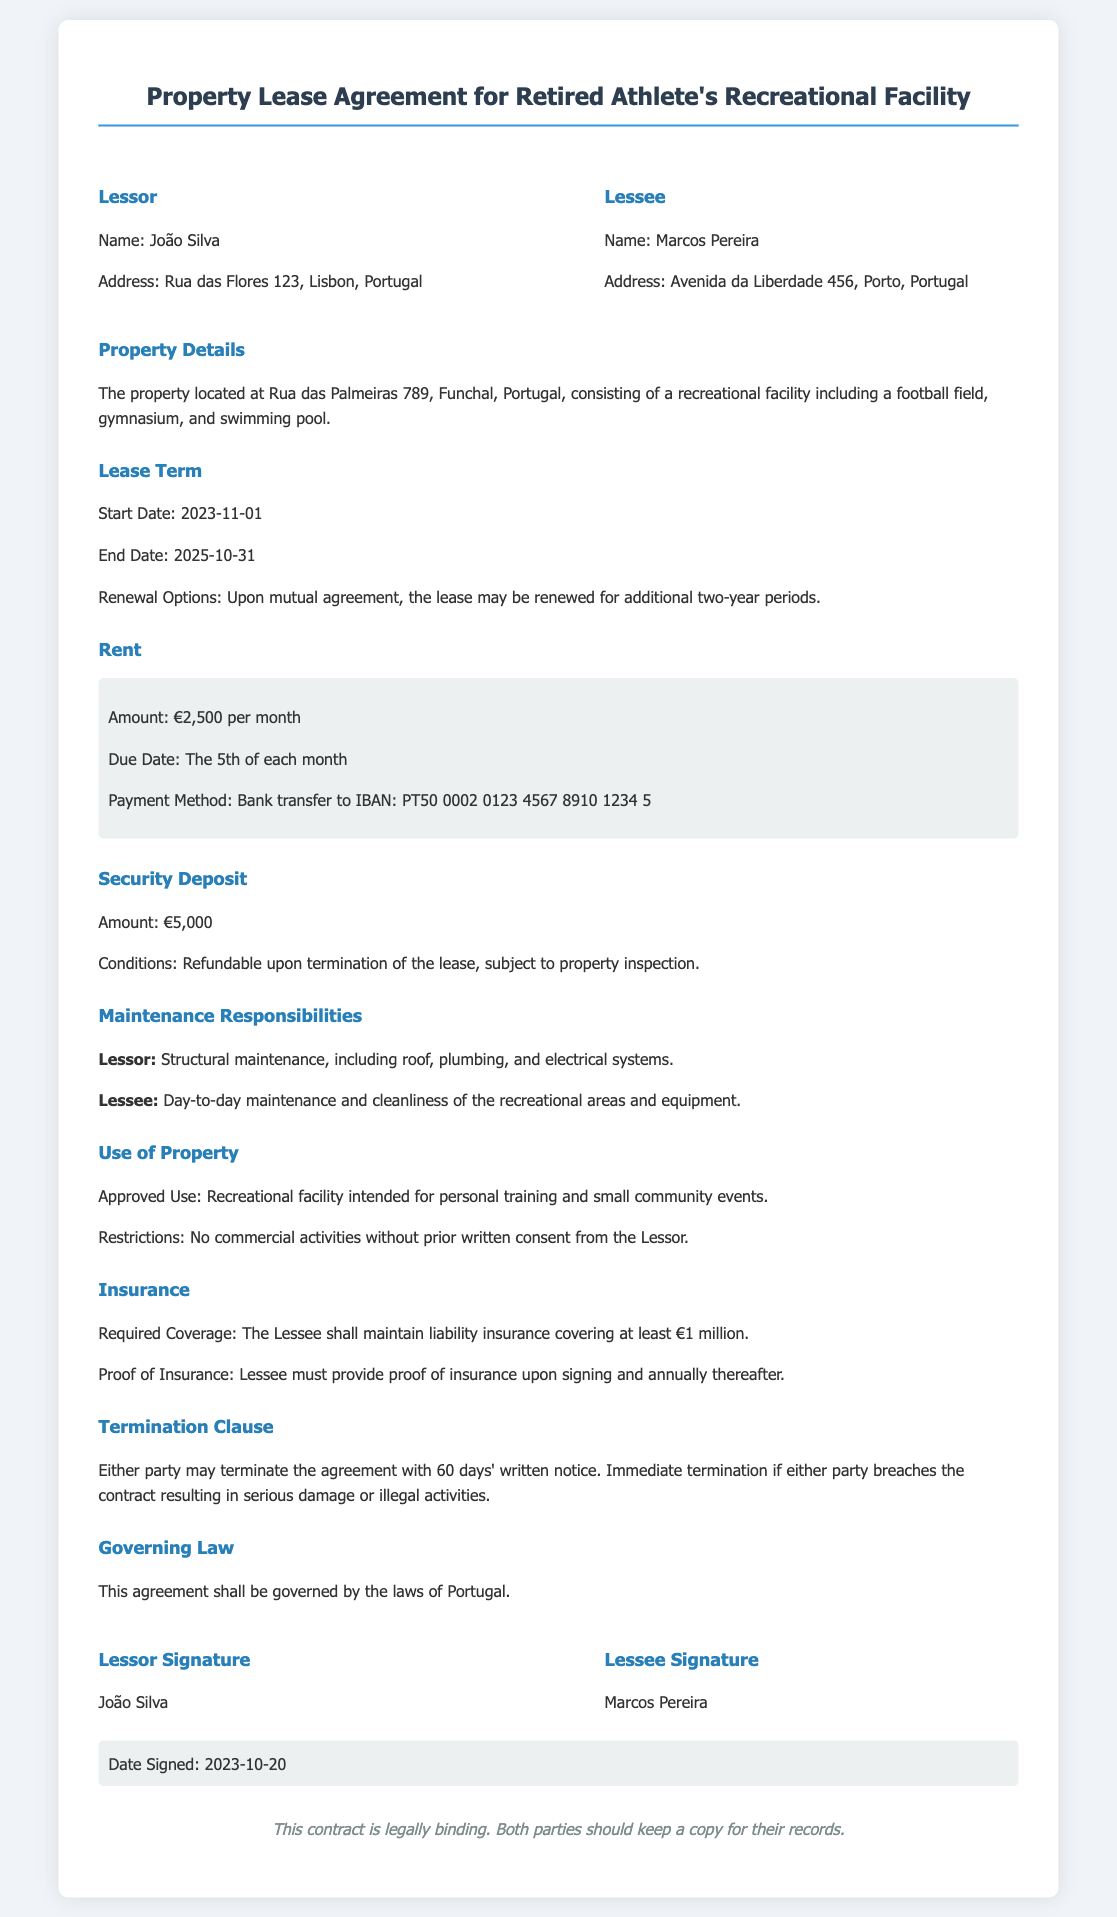What is the name of the lessor? The lessor is João Silva, as stated in the document.
Answer: João Silva What is the address of the lessee? The lessee's address is provided in the document as Avenida da Liberdade 456, Porto, Portugal.
Answer: Avenida da Liberdade 456, Porto, Portugal What is the amount of the monthly rent? The lease agreement specifies a monthly rent amount of €2,500.
Answer: €2,500 What is the lease start date? The lease start date is mentioned as November 1, 2023, in the document.
Answer: 2023-11-01 What is the security deposit amount? The document states the security deposit amount as €5,000.
Answer: €5,000 What is the required liability insurance coverage? The document outlines the required liability insurance coverage as at least €1 million.
Answer: €1 million How long is the lease term? The lease term is from November 1, 2023, to October 31, 2025, making it a two-year duration.
Answer: 2 years What responsibilities does the lessor have? The lessor's responsibilities include structural maintenance, such as roof, plumbing, and electrical systems.
Answer: Structural maintenance What notice period is required for termination? The contract specifies a notice period of 60 days for termination of the agreement.
Answer: 60 days 